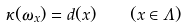Convert formula to latex. <formula><loc_0><loc_0><loc_500><loc_500>\kappa ( \omega _ { x } ) = d ( x ) \quad ( x \in \Lambda )</formula> 